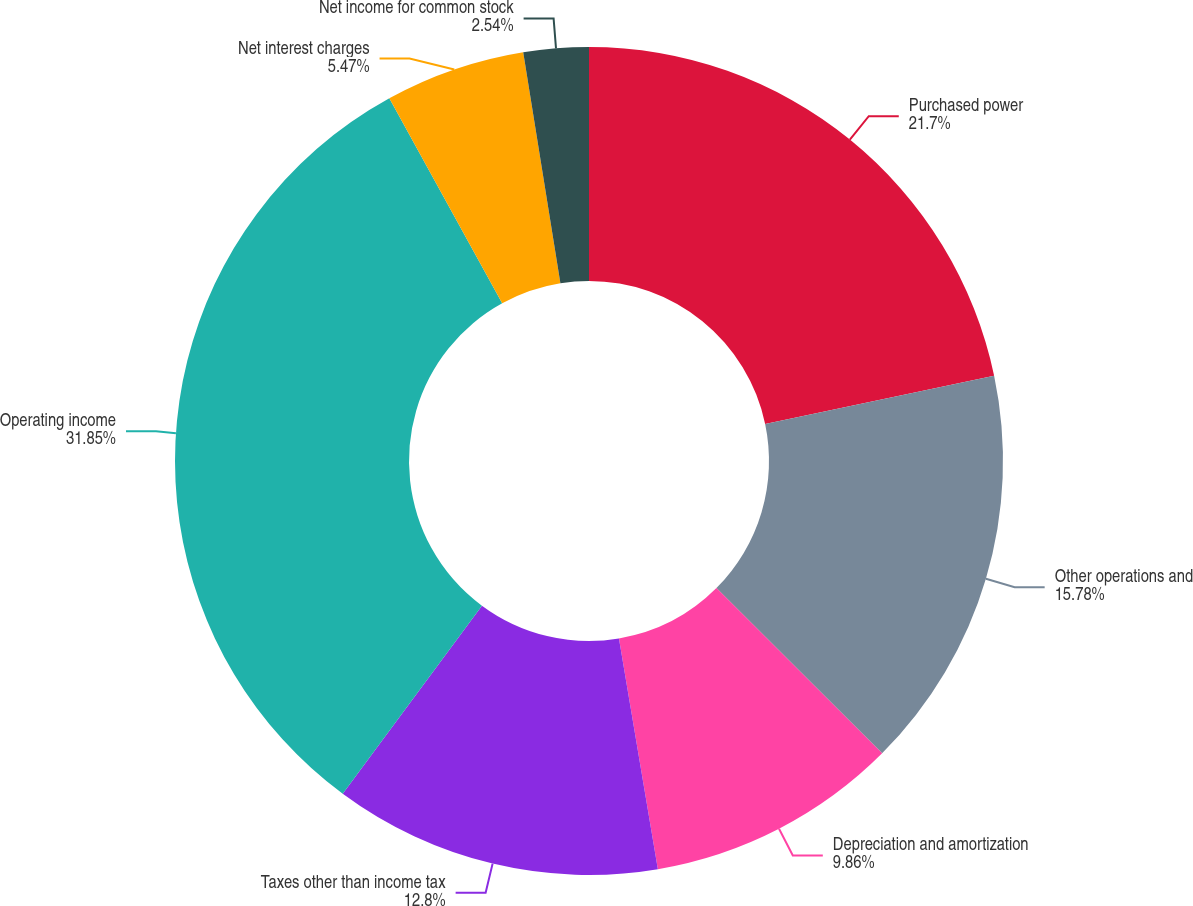Convert chart. <chart><loc_0><loc_0><loc_500><loc_500><pie_chart><fcel>Purchased power<fcel>Other operations and<fcel>Depreciation and amortization<fcel>Taxes other than income tax<fcel>Operating income<fcel>Net interest charges<fcel>Net income for common stock<nl><fcel>21.7%<fcel>15.78%<fcel>9.86%<fcel>12.8%<fcel>31.85%<fcel>5.47%<fcel>2.54%<nl></chart> 